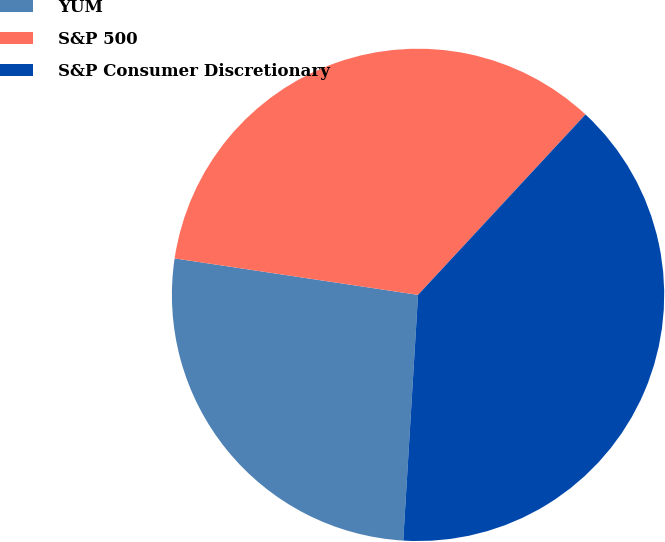Convert chart to OTSL. <chart><loc_0><loc_0><loc_500><loc_500><pie_chart><fcel>YUM<fcel>S&P 500<fcel>S&P Consumer Discretionary<nl><fcel>26.41%<fcel>34.54%<fcel>39.05%<nl></chart> 